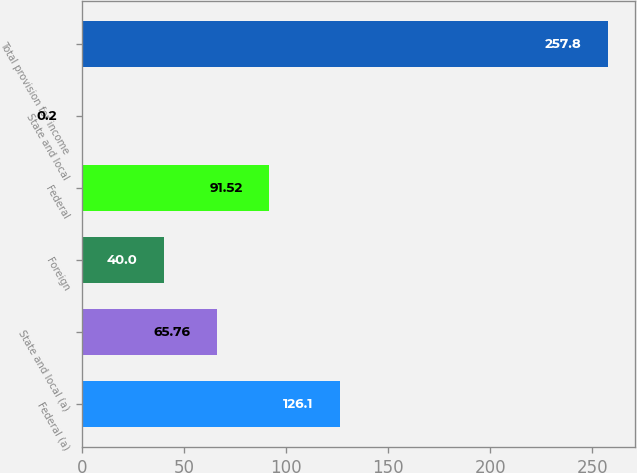Convert chart to OTSL. <chart><loc_0><loc_0><loc_500><loc_500><bar_chart><fcel>Federal (a)<fcel>State and local (a)<fcel>Foreign<fcel>Federal<fcel>State and local<fcel>Total provision for income<nl><fcel>126.1<fcel>65.76<fcel>40<fcel>91.52<fcel>0.2<fcel>257.8<nl></chart> 